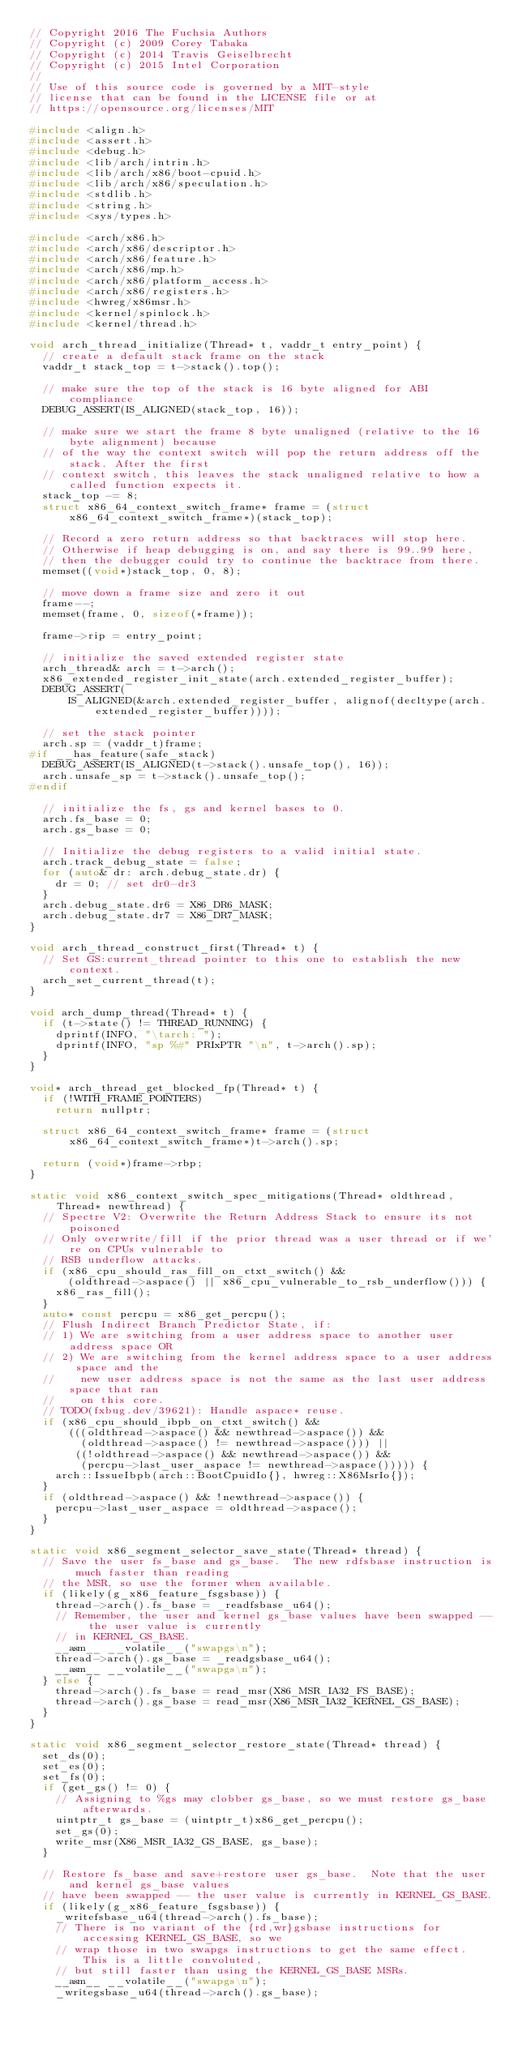<code> <loc_0><loc_0><loc_500><loc_500><_C++_>// Copyright 2016 The Fuchsia Authors
// Copyright (c) 2009 Corey Tabaka
// Copyright (c) 2014 Travis Geiselbrecht
// Copyright (c) 2015 Intel Corporation
//
// Use of this source code is governed by a MIT-style
// license that can be found in the LICENSE file or at
// https://opensource.org/licenses/MIT

#include <align.h>
#include <assert.h>
#include <debug.h>
#include <lib/arch/intrin.h>
#include <lib/arch/x86/boot-cpuid.h>
#include <lib/arch/x86/speculation.h>
#include <stdlib.h>
#include <string.h>
#include <sys/types.h>

#include <arch/x86.h>
#include <arch/x86/descriptor.h>
#include <arch/x86/feature.h>
#include <arch/x86/mp.h>
#include <arch/x86/platform_access.h>
#include <arch/x86/registers.h>
#include <hwreg/x86msr.h>
#include <kernel/spinlock.h>
#include <kernel/thread.h>

void arch_thread_initialize(Thread* t, vaddr_t entry_point) {
  // create a default stack frame on the stack
  vaddr_t stack_top = t->stack().top();

  // make sure the top of the stack is 16 byte aligned for ABI compliance
  DEBUG_ASSERT(IS_ALIGNED(stack_top, 16));

  // make sure we start the frame 8 byte unaligned (relative to the 16 byte alignment) because
  // of the way the context switch will pop the return address off the stack. After the first
  // context switch, this leaves the stack unaligned relative to how a called function expects it.
  stack_top -= 8;
  struct x86_64_context_switch_frame* frame = (struct x86_64_context_switch_frame*)(stack_top);

  // Record a zero return address so that backtraces will stop here.
  // Otherwise if heap debugging is on, and say there is 99..99 here,
  // then the debugger could try to continue the backtrace from there.
  memset((void*)stack_top, 0, 8);

  // move down a frame size and zero it out
  frame--;
  memset(frame, 0, sizeof(*frame));

  frame->rip = entry_point;

  // initialize the saved extended register state
  arch_thread& arch = t->arch();
  x86_extended_register_init_state(arch.extended_register_buffer);
  DEBUG_ASSERT(
      IS_ALIGNED(&arch.extended_register_buffer, alignof(decltype(arch.extended_register_buffer))));

  // set the stack pointer
  arch.sp = (vaddr_t)frame;
#if __has_feature(safe_stack)
  DEBUG_ASSERT(IS_ALIGNED(t->stack().unsafe_top(), 16));
  arch.unsafe_sp = t->stack().unsafe_top();
#endif

  // initialize the fs, gs and kernel bases to 0.
  arch.fs_base = 0;
  arch.gs_base = 0;

  // Initialize the debug registers to a valid initial state.
  arch.track_debug_state = false;
  for (auto& dr: arch.debug_state.dr) {
    dr = 0; // set dr0-dr3
  }
  arch.debug_state.dr6 = X86_DR6_MASK;
  arch.debug_state.dr7 = X86_DR7_MASK;
}

void arch_thread_construct_first(Thread* t) {
  // Set GS:current_thread pointer to this one to establish the new context.
  arch_set_current_thread(t);
}

void arch_dump_thread(Thread* t) {
  if (t->state() != THREAD_RUNNING) {
    dprintf(INFO, "\tarch: ");
    dprintf(INFO, "sp %#" PRIxPTR "\n", t->arch().sp);
  }
}

void* arch_thread_get_blocked_fp(Thread* t) {
  if (!WITH_FRAME_POINTERS)
    return nullptr;

  struct x86_64_context_switch_frame* frame = (struct x86_64_context_switch_frame*)t->arch().sp;

  return (void*)frame->rbp;
}

static void x86_context_switch_spec_mitigations(Thread* oldthread, Thread* newthread) {
  // Spectre V2: Overwrite the Return Address Stack to ensure its not poisoned
  // Only overwrite/fill if the prior thread was a user thread or if we're on CPUs vulnerable to
  // RSB underflow attacks.
  if (x86_cpu_should_ras_fill_on_ctxt_switch() &&
      (oldthread->aspace() || x86_cpu_vulnerable_to_rsb_underflow())) {
    x86_ras_fill();
  }
  auto* const percpu = x86_get_percpu();
  // Flush Indirect Branch Predictor State, if:
  // 1) We are switching from a user address space to another user address space OR
  // 2) We are switching from the kernel address space to a user address space and the
  //    new user address space is not the same as the last user address space that ran
  //    on this core.
  // TODO(fxbug.dev/39621): Handle aspace* reuse.
  if (x86_cpu_should_ibpb_on_ctxt_switch() &&
      (((oldthread->aspace() && newthread->aspace()) &&
        (oldthread->aspace() != newthread->aspace())) ||
       ((!oldthread->aspace() && newthread->aspace()) &&
        (percpu->last_user_aspace != newthread->aspace())))) {
    arch::IssueIbpb(arch::BootCpuidIo{}, hwreg::X86MsrIo{});
  }
  if (oldthread->aspace() && !newthread->aspace()) {
    percpu->last_user_aspace = oldthread->aspace();
  }
}

static void x86_segment_selector_save_state(Thread* thread) {
  // Save the user fs_base and gs_base.  The new rdfsbase instruction is much faster than reading
  // the MSR, so use the former when available.
  if (likely(g_x86_feature_fsgsbase)) {
    thread->arch().fs_base = _readfsbase_u64();
    // Remember, the user and kernel gs_base values have been swapped -- the user value is currently
    // in KERNEL_GS_BASE.
    __asm__ __volatile__("swapgs\n");
    thread->arch().gs_base = _readgsbase_u64();
    __asm__ __volatile__("swapgs\n");
  } else {
    thread->arch().fs_base = read_msr(X86_MSR_IA32_FS_BASE);
    thread->arch().gs_base = read_msr(X86_MSR_IA32_KERNEL_GS_BASE);
  }
}

static void x86_segment_selector_restore_state(Thread* thread) {
  set_ds(0);
  set_es(0);
  set_fs(0);
  if (get_gs() != 0) {
    // Assigning to %gs may clobber gs_base, so we must restore gs_base afterwards.
    uintptr_t gs_base = (uintptr_t)x86_get_percpu();
    set_gs(0);
    write_msr(X86_MSR_IA32_GS_BASE, gs_base);
  }

  // Restore fs_base and save+restore user gs_base.  Note that the user and kernel gs_base values
  // have been swapped -- the user value is currently in KERNEL_GS_BASE.
  if (likely(g_x86_feature_fsgsbase)) {
    _writefsbase_u64(thread->arch().fs_base);
    // There is no variant of the {rd,wr}gsbase instructions for accessing KERNEL_GS_BASE, so we
    // wrap those in two swapgs instructions to get the same effect.  This is a little convoluted,
    // but still faster than using the KERNEL_GS_BASE MSRs.
    __asm__ __volatile__("swapgs\n");
    _writegsbase_u64(thread->arch().gs_base);</code> 